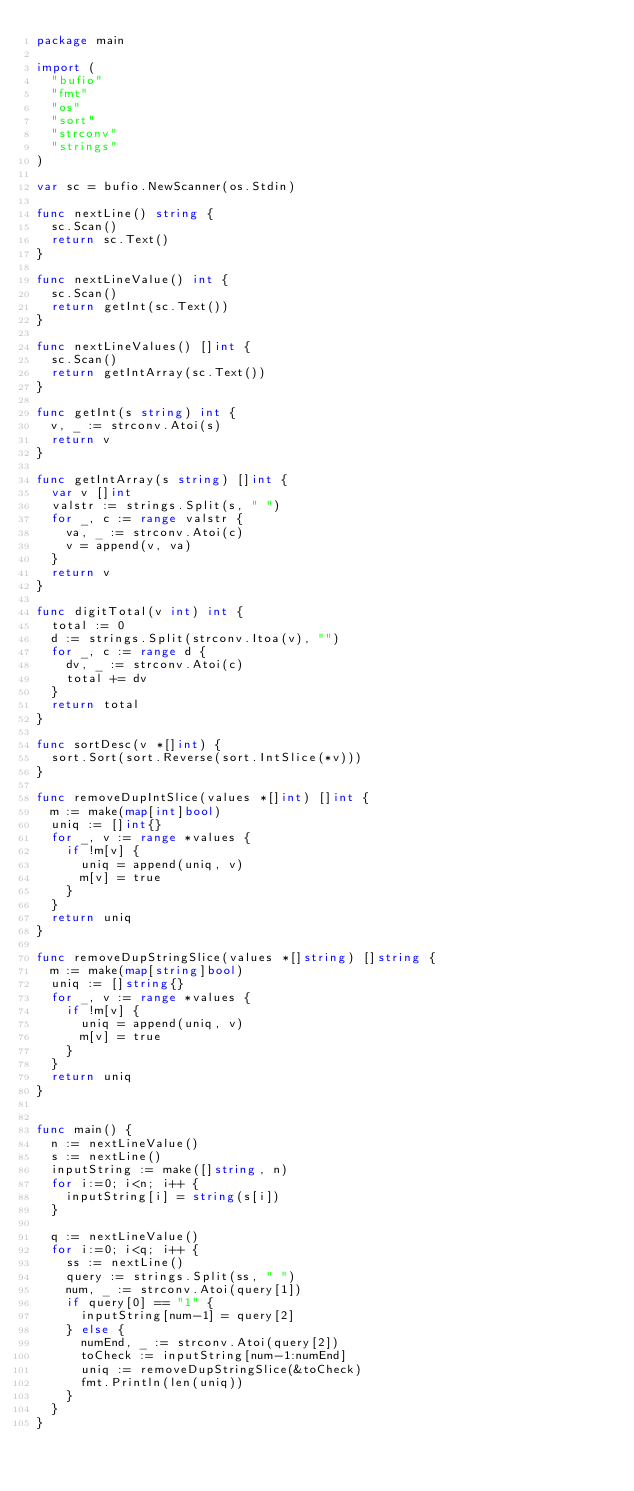Convert code to text. <code><loc_0><loc_0><loc_500><loc_500><_Go_>package main

import (
  "bufio"
  "fmt"
  "os"
  "sort"
  "strconv"
  "strings"
)

var sc = bufio.NewScanner(os.Stdin)

func nextLine() string {
  sc.Scan()
  return sc.Text()
}

func nextLineValue() int {
  sc.Scan()
  return getInt(sc.Text())
}

func nextLineValues() []int {
  sc.Scan()
  return getIntArray(sc.Text())
}

func getInt(s string) int {
  v, _ := strconv.Atoi(s)
  return v
}

func getIntArray(s string) []int {
  var v []int
  valstr := strings.Split(s, " ")
  for _, c := range valstr {
    va, _ := strconv.Atoi(c)
    v = append(v, va)
  }
  return v
}

func digitTotal(v int) int {
  total := 0
  d := strings.Split(strconv.Itoa(v), "")
  for _, c := range d {
    dv, _ := strconv.Atoi(c)
    total += dv
  }
  return total
}

func sortDesc(v *[]int) {
  sort.Sort(sort.Reverse(sort.IntSlice(*v)))
}

func removeDupIntSlice(values *[]int) []int {
  m := make(map[int]bool)
  uniq := []int{}
  for _, v := range *values {
    if !m[v] {
      uniq = append(uniq, v)
      m[v] = true
    }
  }
  return uniq
}

func removeDupStringSlice(values *[]string) []string {
  m := make(map[string]bool)
  uniq := []string{}
  for _, v := range *values {
    if !m[v] {
      uniq = append(uniq, v)
      m[v] = true
    }
  }
  return uniq
}


func main() {
  n := nextLineValue()
  s := nextLine()
  inputString := make([]string, n)
  for i:=0; i<n; i++ {
    inputString[i] = string(s[i])
  }

  q := nextLineValue()
  for i:=0; i<q; i++ {
    ss := nextLine()
    query := strings.Split(ss, " ")
    num, _ := strconv.Atoi(query[1])
    if query[0] == "1" {
      inputString[num-1] = query[2]
    } else {
      numEnd, _ := strconv.Atoi(query[2])
      toCheck := inputString[num-1:numEnd]
      uniq := removeDupStringSlice(&toCheck)
      fmt.Println(len(uniq))
    }
  }
}
</code> 